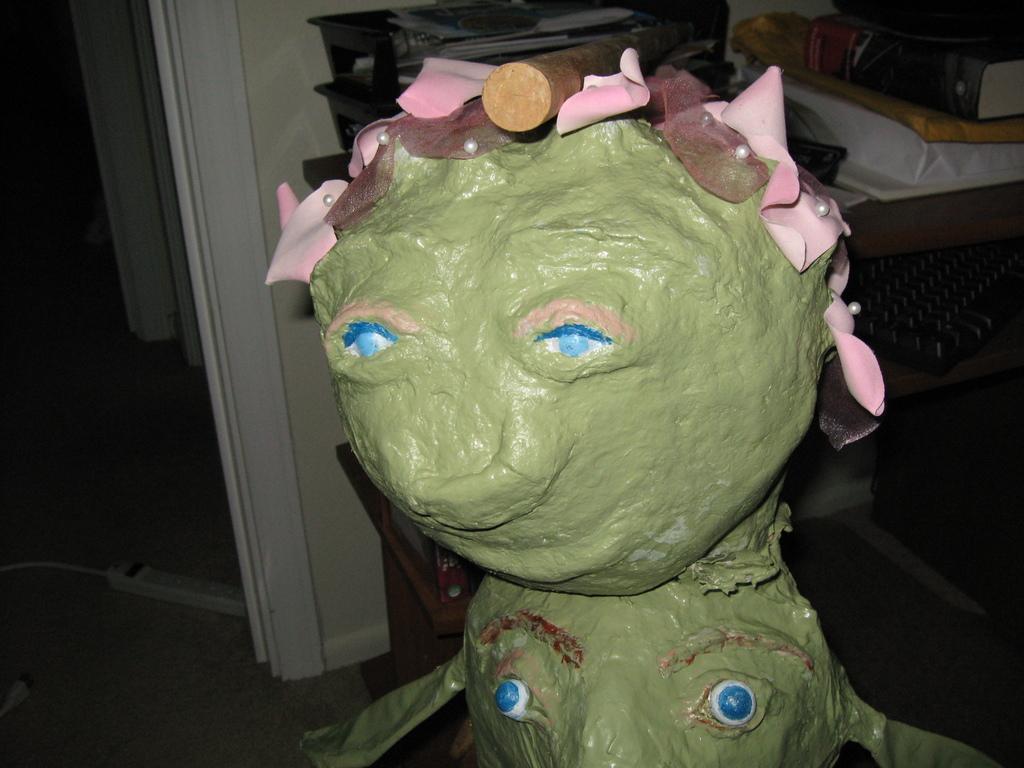In one or two sentences, can you explain what this image depicts? In the center of the image, we can see a doll and in the background, there are some objects. 